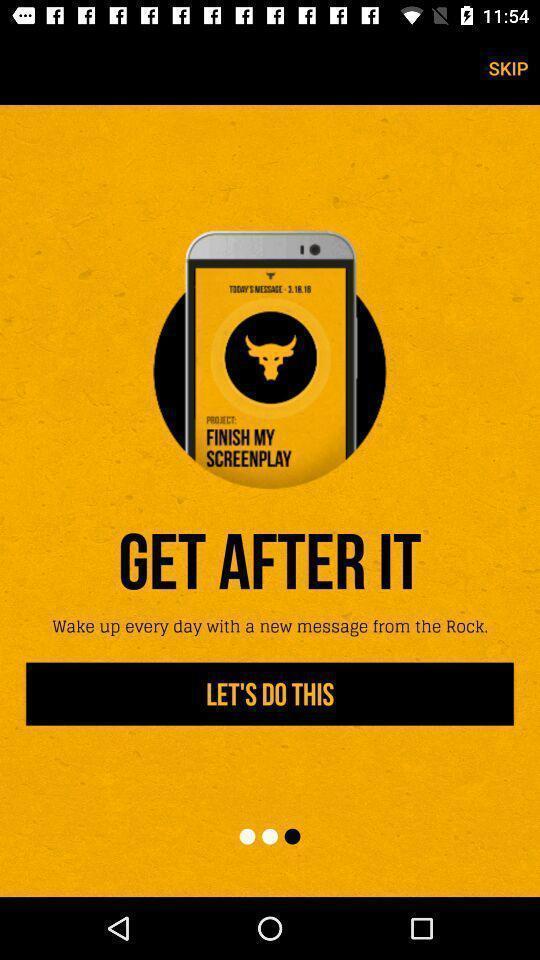Provide a description of this screenshot. Welcome page. 